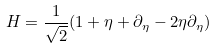Convert formula to latex. <formula><loc_0><loc_0><loc_500><loc_500>H = \frac { 1 } { \sqrt { 2 } } ( 1 + \eta + \partial _ { \eta } - 2 \eta \partial _ { \eta } )</formula> 